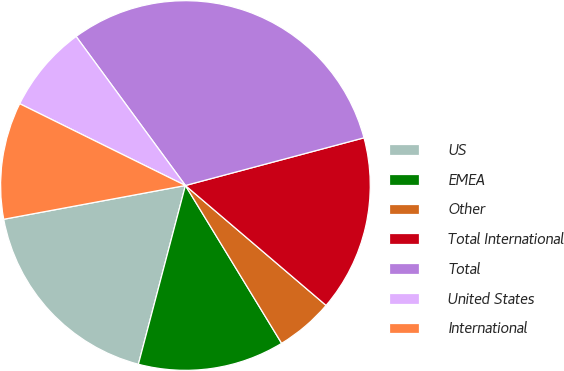Convert chart. <chart><loc_0><loc_0><loc_500><loc_500><pie_chart><fcel>US<fcel>EMEA<fcel>Other<fcel>Total International<fcel>Total<fcel>United States<fcel>International<nl><fcel>17.98%<fcel>12.81%<fcel>5.05%<fcel>15.39%<fcel>30.92%<fcel>7.63%<fcel>10.22%<nl></chart> 